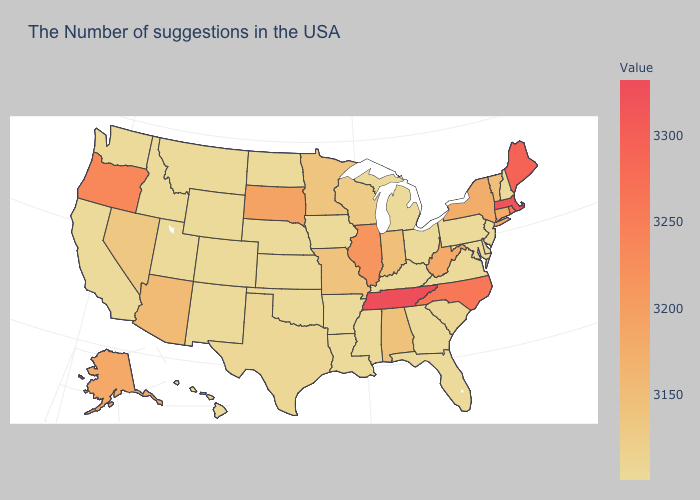Among the states that border New Jersey , does New York have the highest value?
Short answer required. Yes. Is the legend a continuous bar?
Answer briefly. Yes. Does the map have missing data?
Be succinct. No. Among the states that border Texas , which have the highest value?
Give a very brief answer. Louisiana, Arkansas, Oklahoma, New Mexico. Does Wyoming have a lower value than West Virginia?
Answer briefly. Yes. Among the states that border Montana , which have the highest value?
Quick response, please. South Dakota. Which states have the highest value in the USA?
Write a very short answer. Tennessee. Which states have the highest value in the USA?
Keep it brief. Tennessee. 